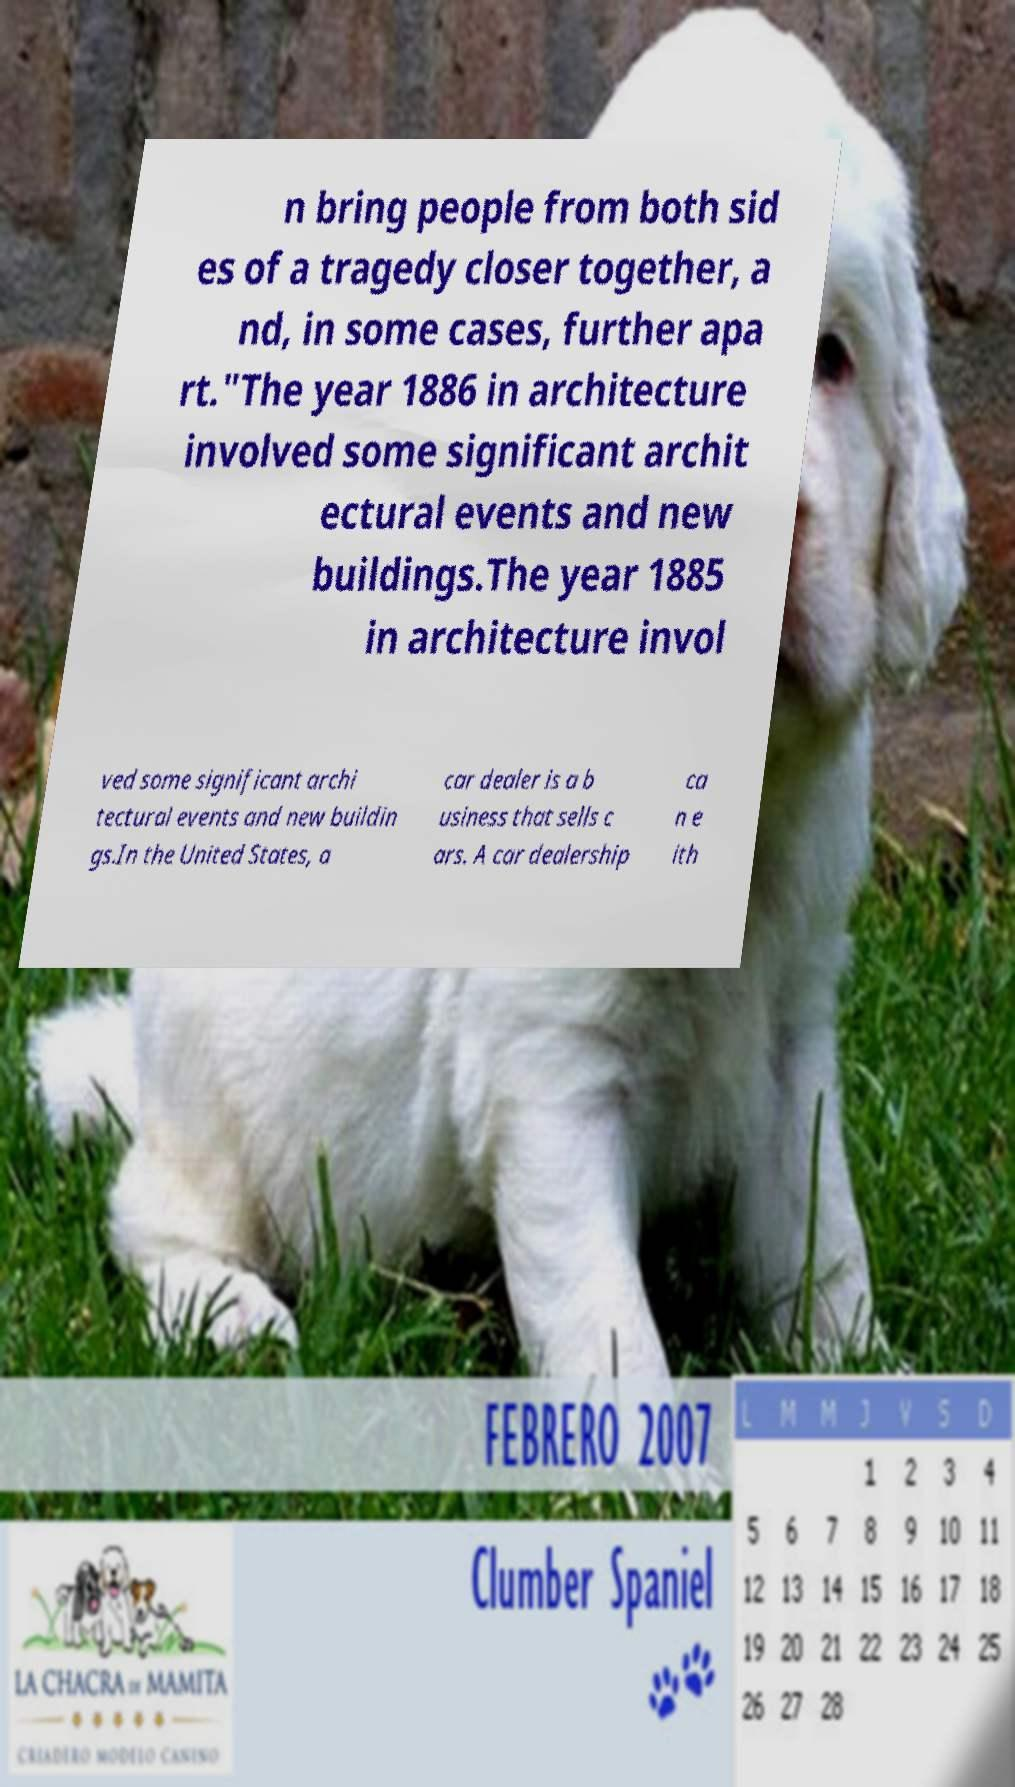Please identify and transcribe the text found in this image. n bring people from both sid es of a tragedy closer together, a nd, in some cases, further apa rt."The year 1886 in architecture involved some significant archit ectural events and new buildings.The year 1885 in architecture invol ved some significant archi tectural events and new buildin gs.In the United States, a car dealer is a b usiness that sells c ars. A car dealership ca n e ith 